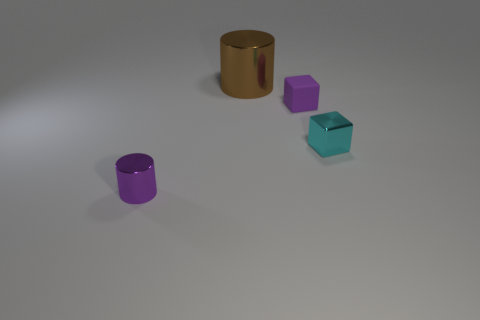Are there any tiny purple matte objects right of the small shiny block?
Your answer should be compact. No. Does the cyan object have the same shape as the brown metal object?
Your answer should be compact. No. What number of other objects are there of the same size as the metal block?
Make the answer very short. 2. What number of things are small metal things that are in front of the metallic cube or large brown metallic cylinders?
Make the answer very short. 2. What color is the big shiny cylinder?
Your response must be concise. Brown. What material is the purple thing in front of the purple matte block?
Keep it short and to the point. Metal. Is the shape of the big brown metal object the same as the purple thing that is behind the purple shiny cylinder?
Provide a succinct answer. No. Are there more brown metal things than blue metal blocks?
Provide a short and direct response. Yes. Are there any other things of the same color as the large cylinder?
Give a very brief answer. No. What shape is the cyan object that is made of the same material as the brown thing?
Your response must be concise. Cube. 